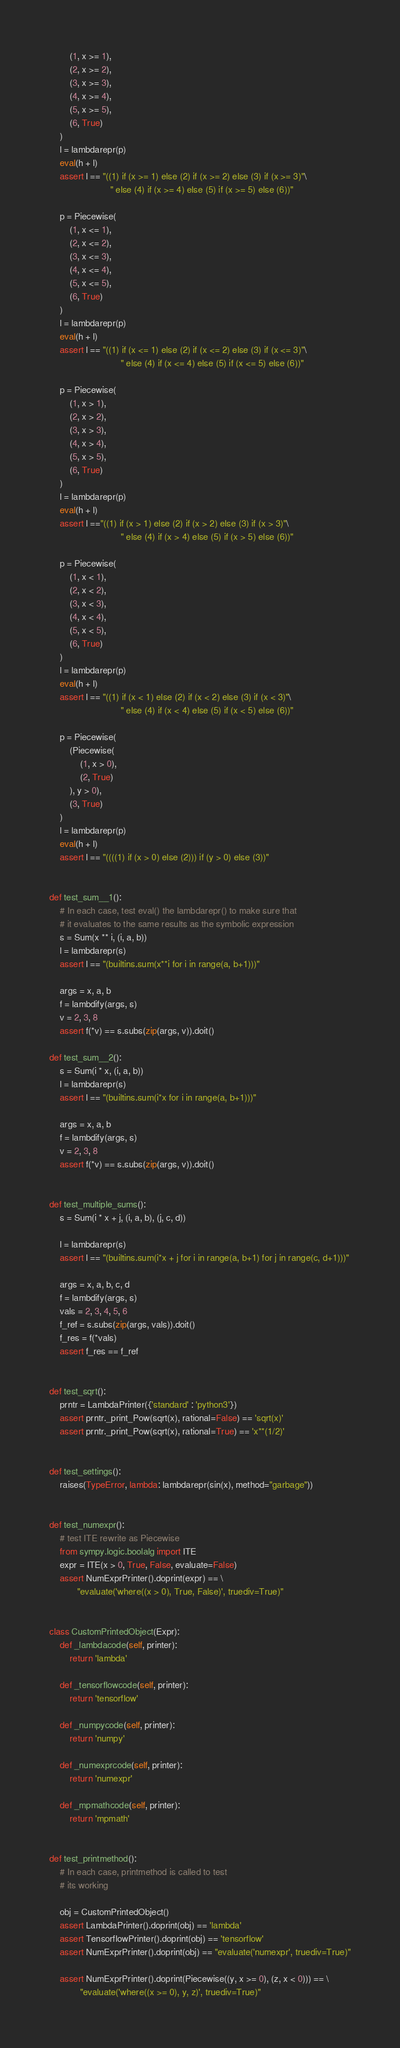Convert code to text. <code><loc_0><loc_0><loc_500><loc_500><_Python_>        (1, x >= 1),
        (2, x >= 2),
        (3, x >= 3),
        (4, x >= 4),
        (5, x >= 5),
        (6, True)
    )
    l = lambdarepr(p)
    eval(h + l)
    assert l == "((1) if (x >= 1) else (2) if (x >= 2) else (3) if (x >= 3)"\
                        " else (4) if (x >= 4) else (5) if (x >= 5) else (6))"

    p = Piecewise(
        (1, x <= 1),
        (2, x <= 2),
        (3, x <= 3),
        (4, x <= 4),
        (5, x <= 5),
        (6, True)
    )
    l = lambdarepr(p)
    eval(h + l)
    assert l == "((1) if (x <= 1) else (2) if (x <= 2) else (3) if (x <= 3)"\
                            " else (4) if (x <= 4) else (5) if (x <= 5) else (6))"

    p = Piecewise(
        (1, x > 1),
        (2, x > 2),
        (3, x > 3),
        (4, x > 4),
        (5, x > 5),
        (6, True)
    )
    l = lambdarepr(p)
    eval(h + l)
    assert l =="((1) if (x > 1) else (2) if (x > 2) else (3) if (x > 3)"\
                            " else (4) if (x > 4) else (5) if (x > 5) else (6))"

    p = Piecewise(
        (1, x < 1),
        (2, x < 2),
        (3, x < 3),
        (4, x < 4),
        (5, x < 5),
        (6, True)
    )
    l = lambdarepr(p)
    eval(h + l)
    assert l == "((1) if (x < 1) else (2) if (x < 2) else (3) if (x < 3)"\
                            " else (4) if (x < 4) else (5) if (x < 5) else (6))"

    p = Piecewise(
        (Piecewise(
            (1, x > 0),
            (2, True)
        ), y > 0),
        (3, True)
    )
    l = lambdarepr(p)
    eval(h + l)
    assert l == "((((1) if (x > 0) else (2))) if (y > 0) else (3))"


def test_sum__1():
    # In each case, test eval() the lambdarepr() to make sure that
    # it evaluates to the same results as the symbolic expression
    s = Sum(x ** i, (i, a, b))
    l = lambdarepr(s)
    assert l == "(builtins.sum(x**i for i in range(a, b+1)))"

    args = x, a, b
    f = lambdify(args, s)
    v = 2, 3, 8
    assert f(*v) == s.subs(zip(args, v)).doit()

def test_sum__2():
    s = Sum(i * x, (i, a, b))
    l = lambdarepr(s)
    assert l == "(builtins.sum(i*x for i in range(a, b+1)))"

    args = x, a, b
    f = lambdify(args, s)
    v = 2, 3, 8
    assert f(*v) == s.subs(zip(args, v)).doit()


def test_multiple_sums():
    s = Sum(i * x + j, (i, a, b), (j, c, d))

    l = lambdarepr(s)
    assert l == "(builtins.sum(i*x + j for i in range(a, b+1) for j in range(c, d+1)))"

    args = x, a, b, c, d
    f = lambdify(args, s)
    vals = 2, 3, 4, 5, 6
    f_ref = s.subs(zip(args, vals)).doit()
    f_res = f(*vals)
    assert f_res == f_ref


def test_sqrt():
    prntr = LambdaPrinter({'standard' : 'python3'})
    assert prntr._print_Pow(sqrt(x), rational=False) == 'sqrt(x)'
    assert prntr._print_Pow(sqrt(x), rational=True) == 'x**(1/2)'


def test_settings():
    raises(TypeError, lambda: lambdarepr(sin(x), method="garbage"))


def test_numexpr():
    # test ITE rewrite as Piecewise
    from sympy.logic.boolalg import ITE
    expr = ITE(x > 0, True, False, evaluate=False)
    assert NumExprPrinter().doprint(expr) == \
           "evaluate('where((x > 0), True, False)', truediv=True)"


class CustomPrintedObject(Expr):
    def _lambdacode(self, printer):
        return 'lambda'

    def _tensorflowcode(self, printer):
        return 'tensorflow'

    def _numpycode(self, printer):
        return 'numpy'

    def _numexprcode(self, printer):
        return 'numexpr'

    def _mpmathcode(self, printer):
        return 'mpmath'


def test_printmethod():
    # In each case, printmethod is called to test
    # its working

    obj = CustomPrintedObject()
    assert LambdaPrinter().doprint(obj) == 'lambda'
    assert TensorflowPrinter().doprint(obj) == 'tensorflow'
    assert NumExprPrinter().doprint(obj) == "evaluate('numexpr', truediv=True)"

    assert NumExprPrinter().doprint(Piecewise((y, x >= 0), (z, x < 0))) == \
            "evaluate('where((x >= 0), y, z)', truediv=True)"
</code> 